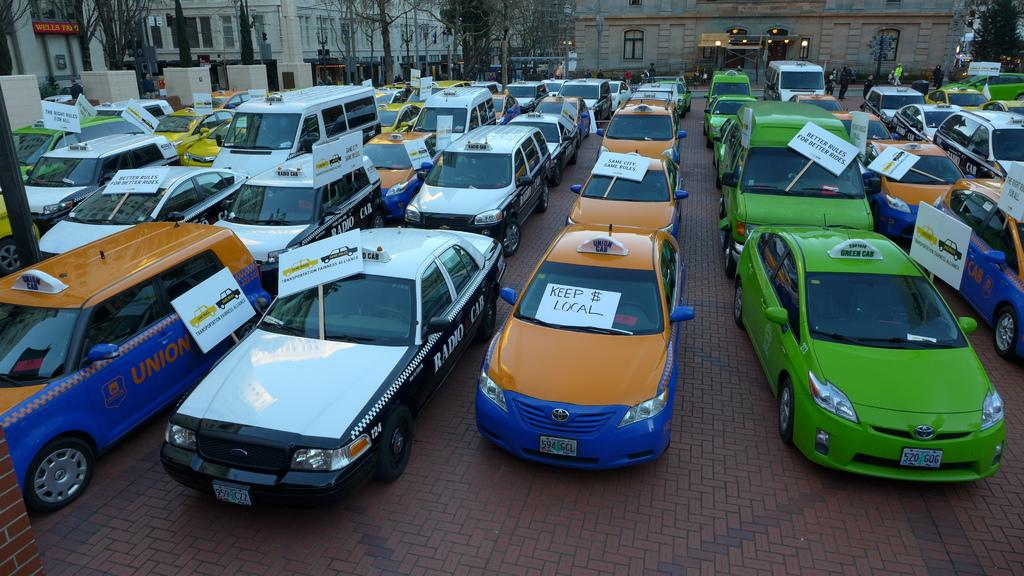<image>
Share a concise interpretation of the image provided. the word keep is on the orange car 